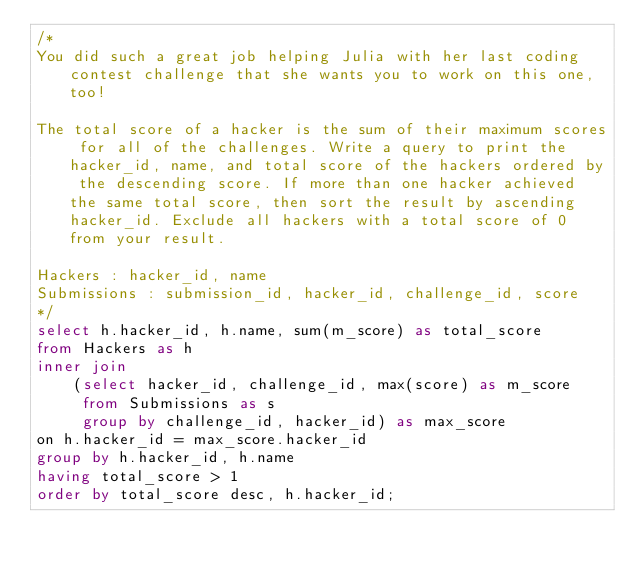Convert code to text. <code><loc_0><loc_0><loc_500><loc_500><_SQL_>/*
You did such a great job helping Julia with her last coding contest challenge that she wants you to work on this one, too!

The total score of a hacker is the sum of their maximum scores for all of the challenges. Write a query to print the hacker_id, name, and total score of the hackers ordered by the descending score. If more than one hacker achieved the same total score, then sort the result by ascending hacker_id. Exclude all hackers with a total score of 0 from your result.

Hackers : hacker_id, name
Submissions : submission_id, hacker_id, challenge_id, score
*/
select h.hacker_id, h.name, sum(m_score) as total_score
from Hackers as h
inner join
    (select hacker_id, challenge_id, max(score) as m_score
     from Submissions as s
     group by challenge_id, hacker_id) as max_score
on h.hacker_id = max_score.hacker_id
group by h.hacker_id, h.name
having total_score > 1
order by total_score desc, h.hacker_id;
</code> 